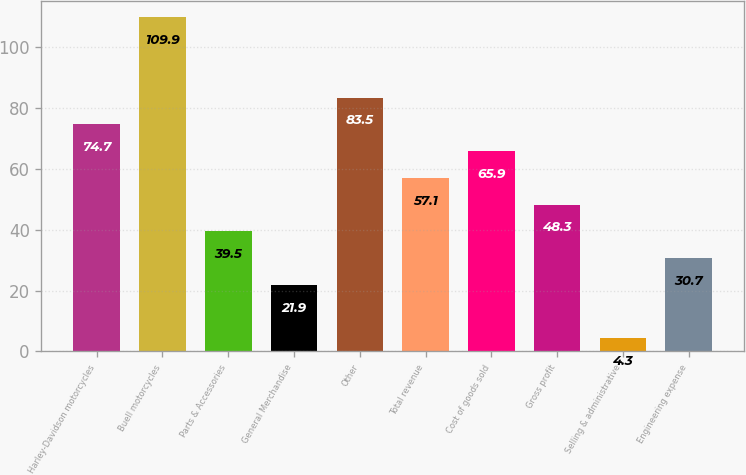Convert chart to OTSL. <chart><loc_0><loc_0><loc_500><loc_500><bar_chart><fcel>Harley-Davidson motorcycles<fcel>Buell motorcycles<fcel>Parts & Accessories<fcel>General Merchandise<fcel>Other<fcel>Total revenue<fcel>Cost of goods sold<fcel>Gross profit<fcel>Selling & administrative<fcel>Engineering expense<nl><fcel>74.7<fcel>109.9<fcel>39.5<fcel>21.9<fcel>83.5<fcel>57.1<fcel>65.9<fcel>48.3<fcel>4.3<fcel>30.7<nl></chart> 